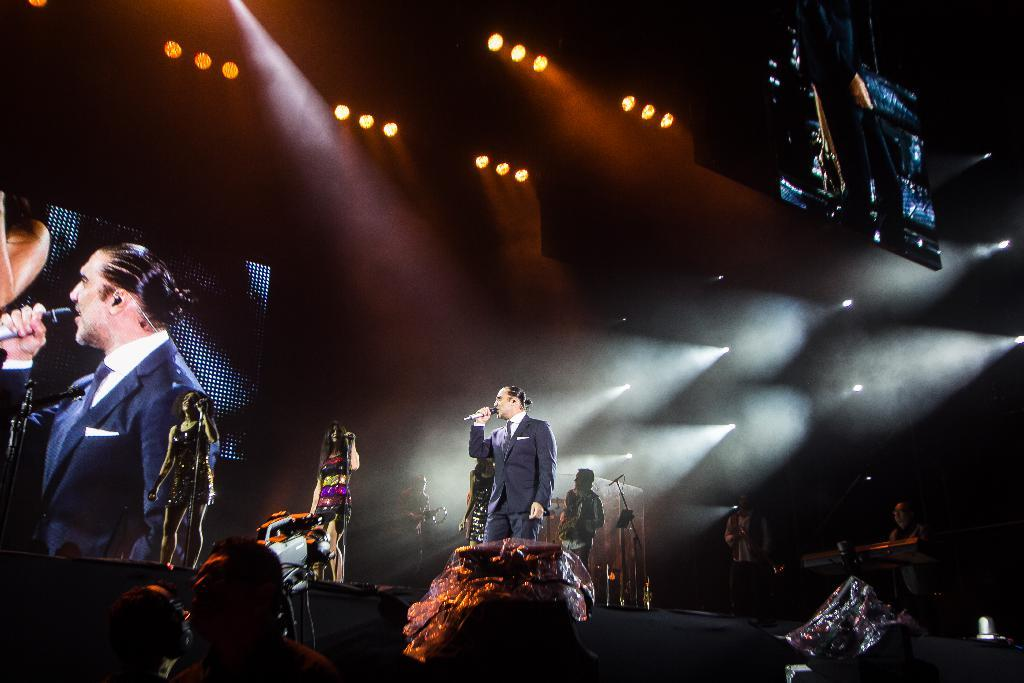What can be seen at the top of the image? There are lights visible at the top of the image. What are the people in the image doing? The people are standing and singing. What objects are the people holding in their hands? The people are holding microphones in their hands. Can you tell me how many teeth are visible in the image? There are no teeth visible in the image. What type of growth is occurring on the people's heads in the image? There is no growth visible on the people's heads in the image. 